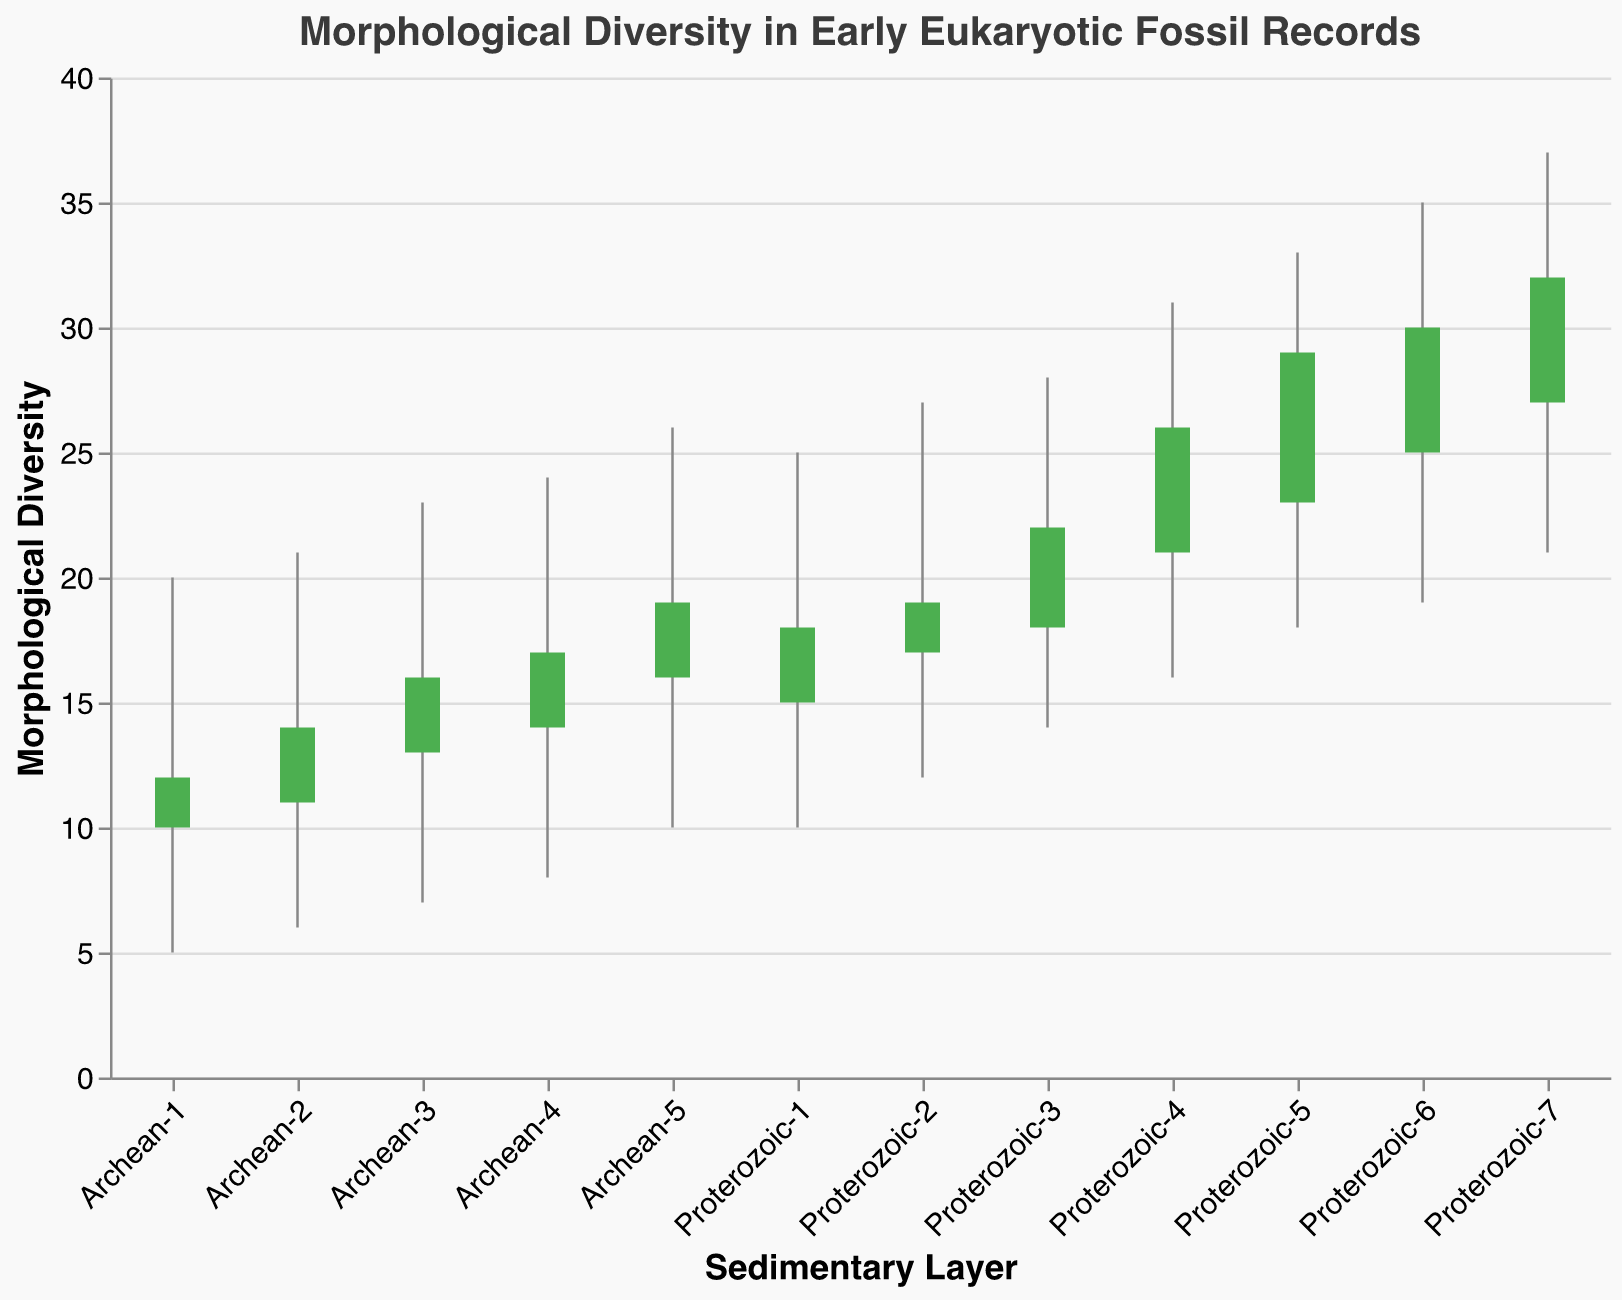How many sedimentary layers are presented in the chart? Count the unique sedimentary layers listed on the x-axis. There are seven layers labeled Proterozoic-1 to Proterozoic-7 and five labeled Archean-1 to Archean-5.
Answer: 12 What is the highest recorded morphological diversity in the chart? Identify the maximum value in the y-axis range. The highest value in the dataset is the high point of 37 for the layer Proterozoic-7.
Answer: 37 Which layer shows the highest closing value for morphological diversity? Look at the y-values where the Closing values are marked. The highest closing value of 32 corresponds to the layer Proterozoic-7.
Answer: Proterozoic-7 In which layers does morphological diversity increase from opening to closing? Identify the bars where the closing value is higher than the opening value, indicated by green bars. These are Proterozoic-1 to Proterozoic-7 and Archean-2, Archean-3, Archean-4, Archean-5.
Answer: Proterozoic-1 to Proterozoic-7, Archean-2, Archean-3, Archean-4, Archean-5 Which sedimentary layer has the largest range in morphological diversity? Calculate the range for each layer by subtracting the Low value from the High value. The largest range is 16, in layer Proterozoic-7 (37 - 21) and Proterozoic-5 (33 - 18).
Answer: Proterozoic-7, Proterozoic-5 What is the average closing value for morphological diversity in Archean layers? Add the Closing values for Archean layers (12, 14, 16, 17, 19) and divide by the number of layers (5). The sum is 78, so 78/5 = 15.6.
Answer: 15.6 Compare the closing values of Proterozoic-5 and Archean-5 layers. Which one is greater? Look at the closing values of these layers. Proterozoic-5 has a value of 29, and Archean-5 has a value of 19. The closing value for Proterozoic-5 is greater.
Answer: Proterozoic-5 In the Proterozoic period, which layer shows the smallest increase in morphological diversity from opening to closing? Calculate the increase by subtracting the Opening value from the Closing value for each Proterozoic layer. The smallest increase is 1, in Proterozoic-2 (19 - 17).
Answer: Proterozoic-2 What is the general trend in morphological diversity from Archean to Proterozoic layers? Observing the data, the trend shows a gradual increase in both the Opening and Closing values as we move from Archean to Proterozoic layers.
Answer: Increase 